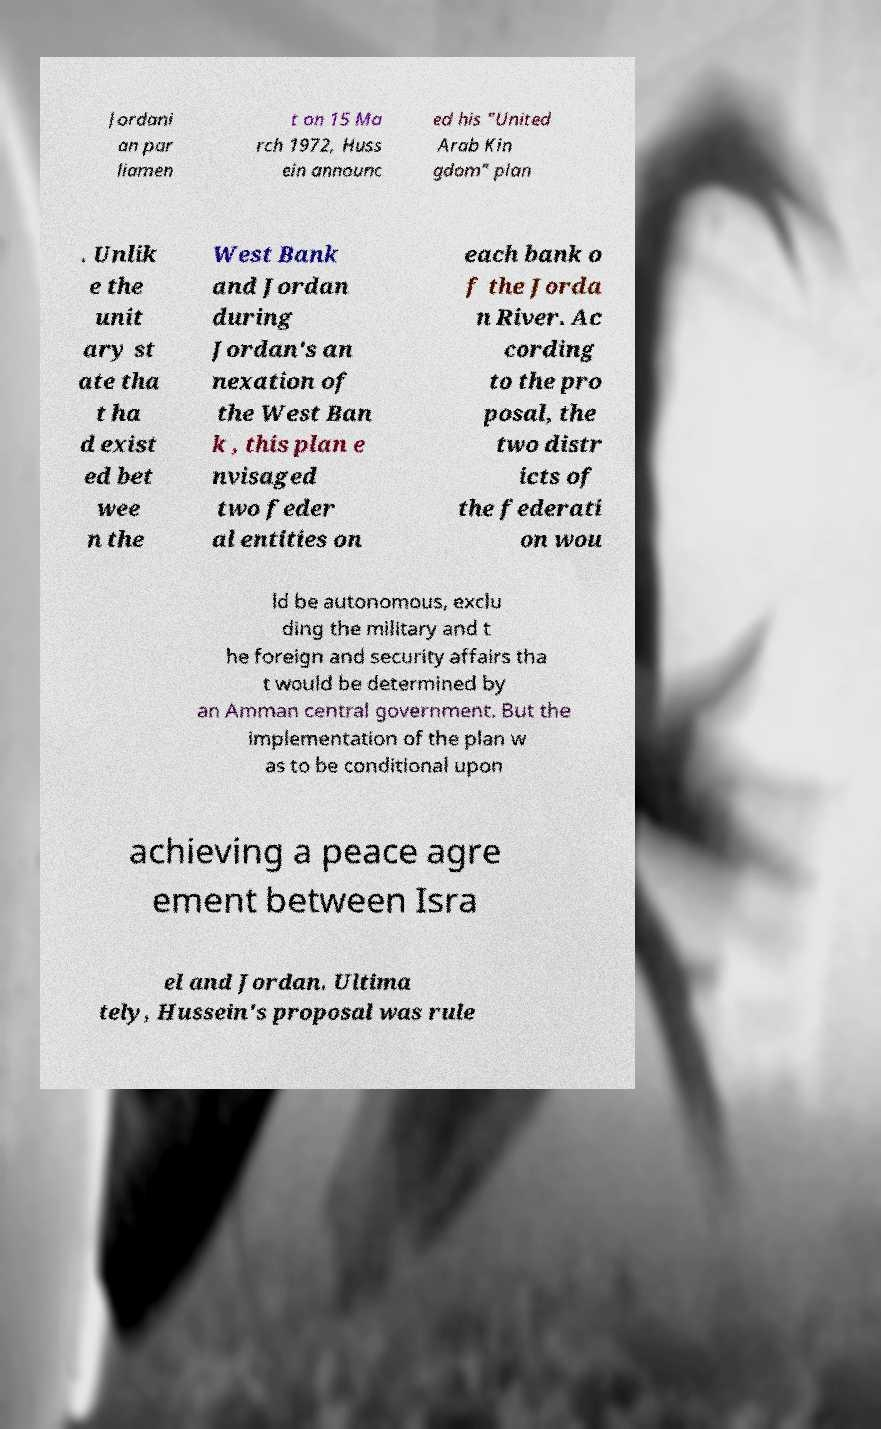Could you assist in decoding the text presented in this image and type it out clearly? Jordani an par liamen t on 15 Ma rch 1972, Huss ein announc ed his "United Arab Kin gdom" plan . Unlik e the unit ary st ate tha t ha d exist ed bet wee n the West Bank and Jordan during Jordan's an nexation of the West Ban k , this plan e nvisaged two feder al entities on each bank o f the Jorda n River. Ac cording to the pro posal, the two distr icts of the federati on wou ld be autonomous, exclu ding the military and t he foreign and security affairs tha t would be determined by an Amman central government. But the implementation of the plan w as to be conditional upon achieving a peace agre ement between Isra el and Jordan. Ultima tely, Hussein's proposal was rule 